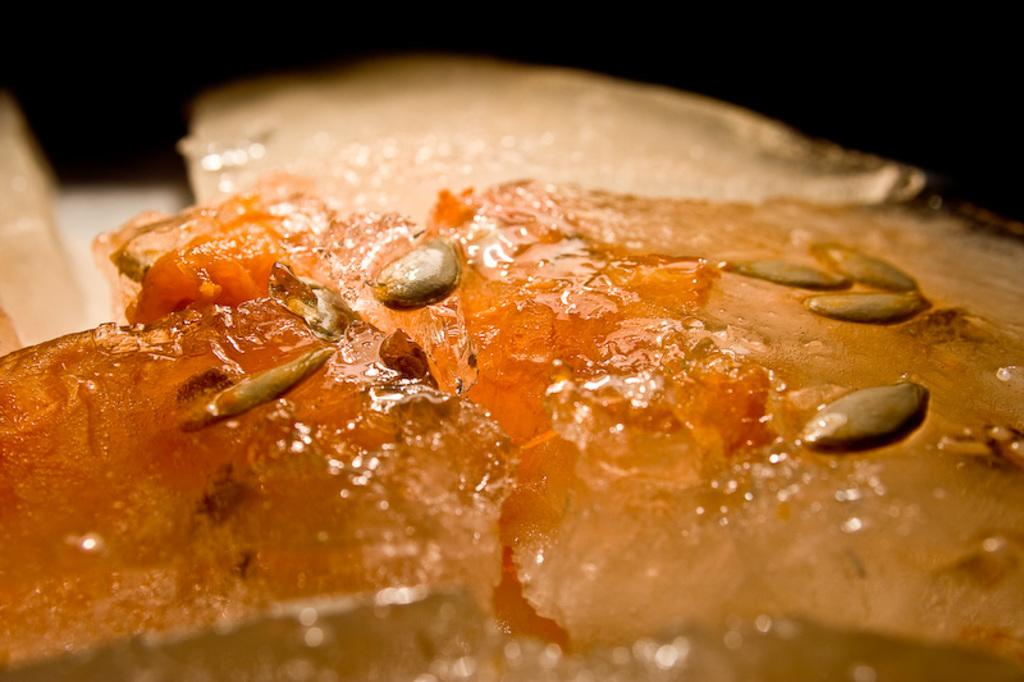What is the main subject of the image? The main subject of the image is a food item. What type of seed can be seen growing in the lace pattern on the church in the image? There is no church, seed, or lace pattern present in the image. 